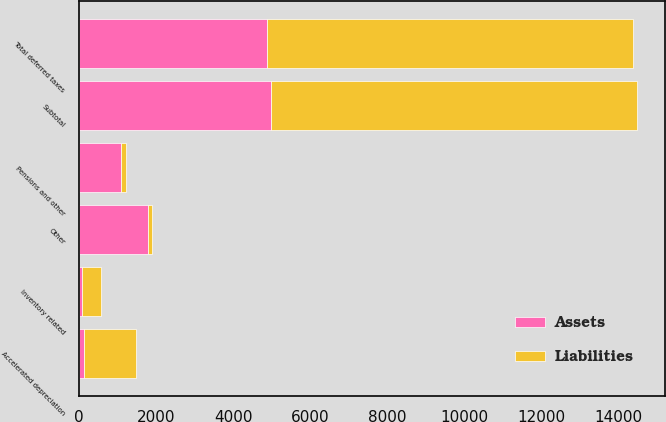<chart> <loc_0><loc_0><loc_500><loc_500><stacked_bar_chart><ecel><fcel>Inventory related<fcel>Accelerated depreciation<fcel>Pensions and other<fcel>Other<fcel>Subtotal<fcel>Total deferred taxes<nl><fcel>Assets<fcel>79<fcel>129<fcel>1098<fcel>1798<fcel>4983<fcel>4876<nl><fcel>Liabilities<fcel>488<fcel>1348<fcel>109<fcel>91<fcel>9506<fcel>9506<nl></chart> 